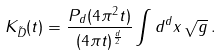Convert formula to latex. <formula><loc_0><loc_0><loc_500><loc_500>K _ { \tilde { D } } ( t ) = \frac { P _ { d } ( 4 \pi ^ { 2 } t ) } { ( 4 \pi t ) ^ { \frac { d } { 2 } } } \int d ^ { d } x \, \sqrt { g } \, .</formula> 